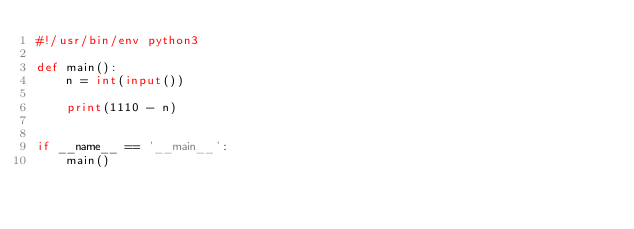<code> <loc_0><loc_0><loc_500><loc_500><_Python_>#!/usr/bin/env python3

def main():
    n = int(input())

    print(1110 - n)


if __name__ == '__main__':
    main()

</code> 